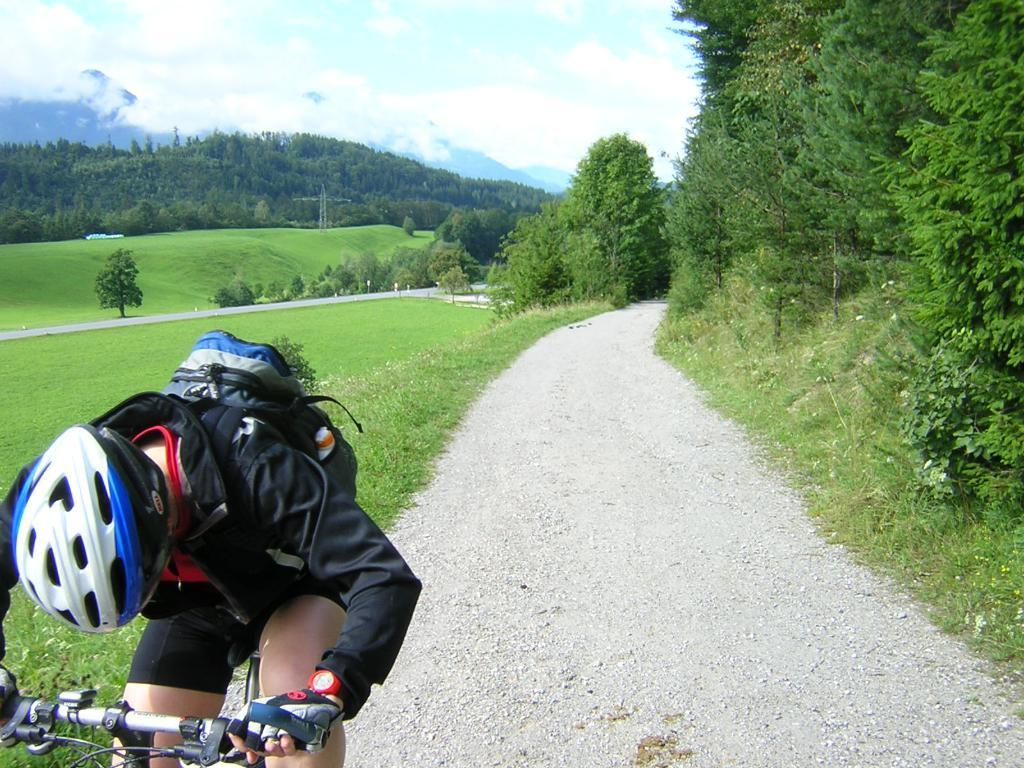What can be seen at the top of the image? The sky with clouds is visible at the top of the image. What type of vegetation is present in the image? There are trees and grass in the image. What activity is the person in the image engaged in? A person wearing a helmet and a backpack is riding a bicycle in the image. What structure can be seen in the image? There is a tower in the image. What book is the person reading while riding the bicycle in the image? There is no book present in the image; the person is riding a bicycle while wearing a helmet and a backpack. What pen is the person using to write while riding the bicycle in the image? There is no pen or writing activity present in the image; the person is simply riding a bicycle. 